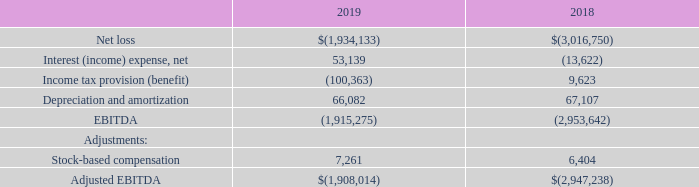Non-GAAP Financial Measures
Management believes that certain non-GAAP financial measures may be useful to investors in certain instances to provide additional meaningful comparisons between current

results and results in prior operating periods. Adjusted earnings before interest, taxes, depreciation, amortization and stock-based compensation (“Adjusted EBITDA”) is a

metric used by management and frequently used by the financial community. Adjusted EBITDA from operations provides insight into an organization’s operating trends and

facilitates comparisons between peer companies, since interest, taxes, depreciation, amortization and stock-based compensation can differ greatly between organizations as a

result of differing capital structures and tax strategies. Adjusted EBITDA from operations is one of the measures used for determining our debt covenant compliance. Adjusted

EBITDA from operations excludes certain items that are unusual in nature or not comparable from period to period. While management believes that non-GAAP measurements

are useful supplemental information, such adjusted results are not intended to replace our GAAP financial results. Adjusted EBITDA from operations is not, and should not be

considered, an alternative to net income (loss), operating income (loss), or any other measure for determining operating performance or liquidity, as determined under

accounting principles generally accepted in the United States (GAAP). In assessing the overall health of its business for the years ended December 31, 2019 and 2018, the

Company excluded items in the following general categories described below:
Stock-based compensation: The Company believes that because of the variety of equity awards used by companies, varying methodologies for determining stock-based compensation and the assumptions and estimates involved in those determinations, the exclusion of non-cash stock-based compensation enhances the ability of management and investors to understand the impact of non-cash stock-based compensation on our operating results. Further, the Company believes that excluding stockbased compensation expense allows for a more transparent comparison of its financial results to the previous year.
RECONCILIATION OF NET LOSS TO ADJUSTED EBITDA FOR THE YEARS ENDED DECEMBER 31,
Liquidity and Capital Resources
For the year ended December 31, 2019, the Company reported a net loss of $1,934,133 and had cash used in operating activities of $1,875,846, and ended the year with an

accumulated deficit of $125,105,539 and total current assets in excess of current liabilities of $4,187,449. At December 31, 2019, the Company had $3,300,600 of cash and

approximately $424,000 of availability on its credit facility. The credit facility is a $2,000,000 line of credit, which is subject to a borrowing base calculation based on the

Company’s eligible accounts receivable and eligible inventory each- multiplied by an applicable advance rate, with an overall limitation tied to the Company’s eligible accounts

receivable. As of December 31, 2019, we had borrowing capacity of $1,102,917 and an outstanding balance of $624,347, resulting in the approximate availability of $424,000

on the credit facility. During the twelve-month period between January 1, 2019 and December 31, 2019, the Company’s cash balance decreased from $4,678,891 to $3,300,600,

or approximately $115,000 per month. In comparison, during the twelve-month period between January 1, 2018 and December 31, 2018, the Company’s cash balance decreased

from $8,385,595 to $4,678,891, or approximately $309,000 per month. This improvement is the result of improved revenues and cost management efforts.
What is adjusted EBITDA? Adjusted earnings before interest, taxes, depreciation, amortization and stock-based compensation. What is the adjusted EBITDA from operations used for? Used for determining our debt covenant compliance. What was the net loss reported for the year ended December 31, 2019? $1,934,133. Which year has the higher stock-based compensation? Compare the values of the stock-based compensation between the two years, find the year with the higher stock-based compensation
Answer: 2019. What is the percentage change in net loss from 2018 to 2019?
Answer scale should be: percent. (1,934,133-3,016,750)/3,016,750
Answer: -35.89. What is the percentage change in the cash balance from January 1, 2019 to December 31, 2019?
Answer scale should be: percent. (3,300,600-4,678,891)/4,678,891
Answer: -29.46. 